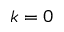<formula> <loc_0><loc_0><loc_500><loc_500>k = 0</formula> 